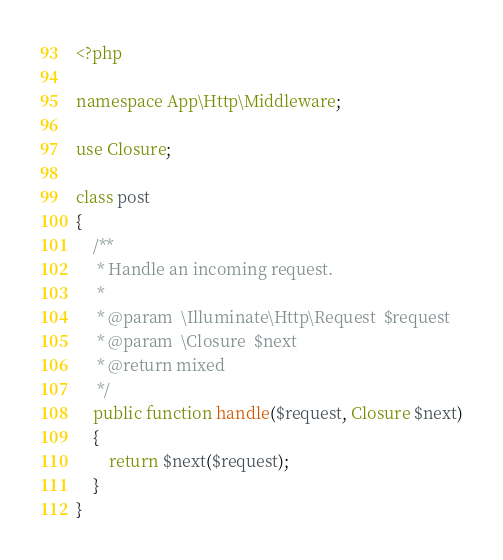<code> <loc_0><loc_0><loc_500><loc_500><_PHP_><?php

namespace App\Http\Middleware;

use Closure;

class post
{
    /**
     * Handle an incoming request.
     *
     * @param  \Illuminate\Http\Request  $request
     * @param  \Closure  $next
     * @return mixed
     */
    public function handle($request, Closure $next)
    {
        return $next($request);
    }
}
</code> 